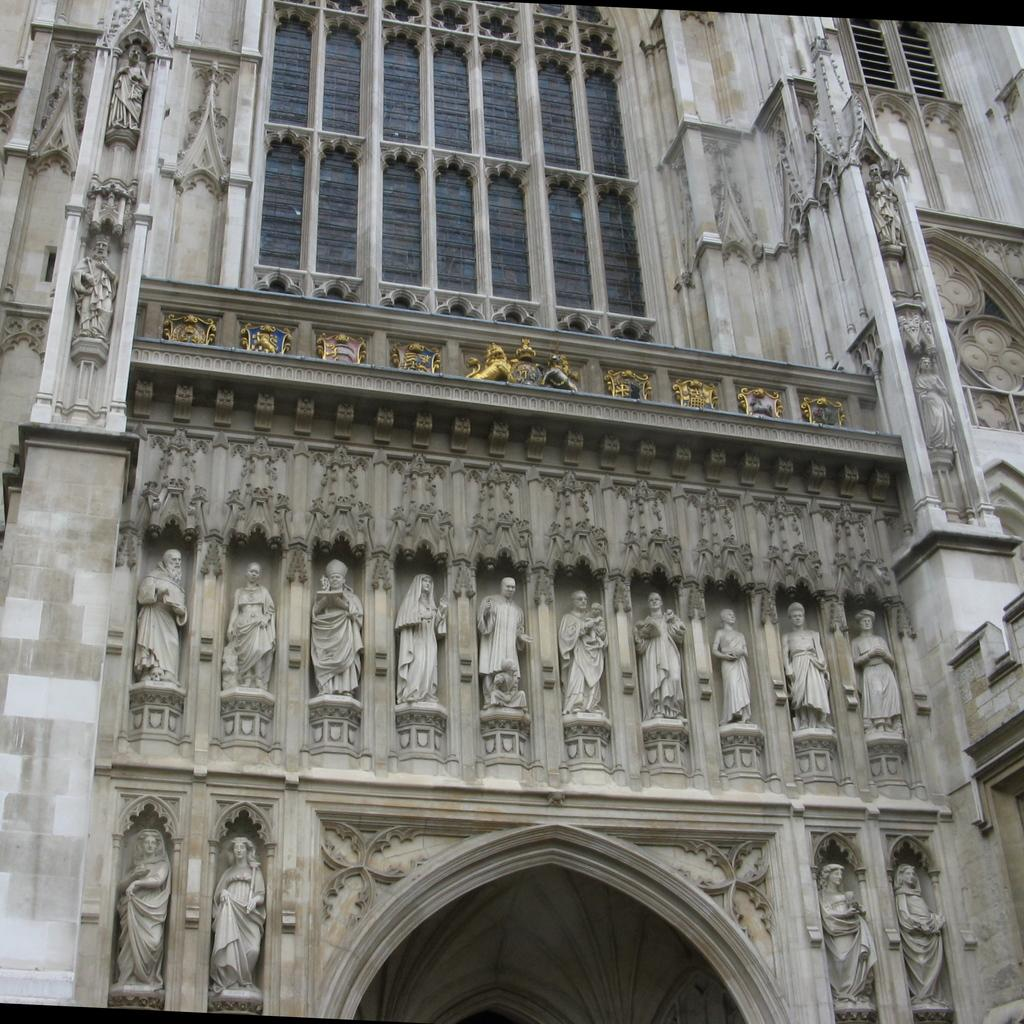What type of structure is present in the image? There is a building in the image. What are some of the features of the building? The building has walls, glass windows, pillars, sculptures, an arch, and other designs on the walls. What type of country can be seen in the image? There is no country visible in the image; it features a building with various architectural elements. Is there a ship docked near the building in the image? There is no ship present in the image; it only shows a building with various features. 